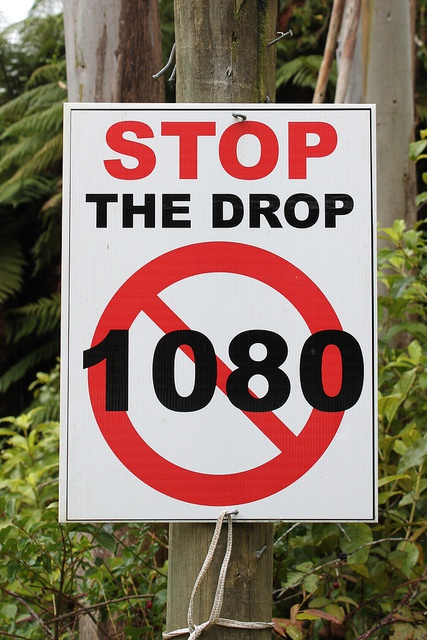Describe the objects in this image and their specific colors. I can see a stop sign in white, lightgray, red, black, and darkgray tones in this image. 